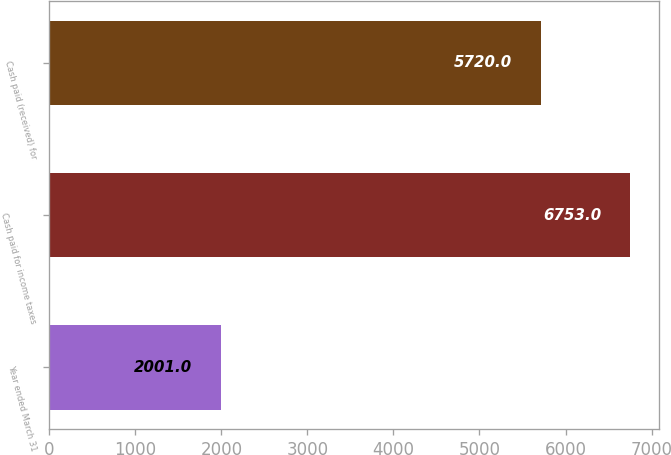<chart> <loc_0><loc_0><loc_500><loc_500><bar_chart><fcel>Year ended March 31<fcel>Cash paid for income taxes<fcel>Cash paid (received) for<nl><fcel>2001<fcel>6753<fcel>5720<nl></chart> 